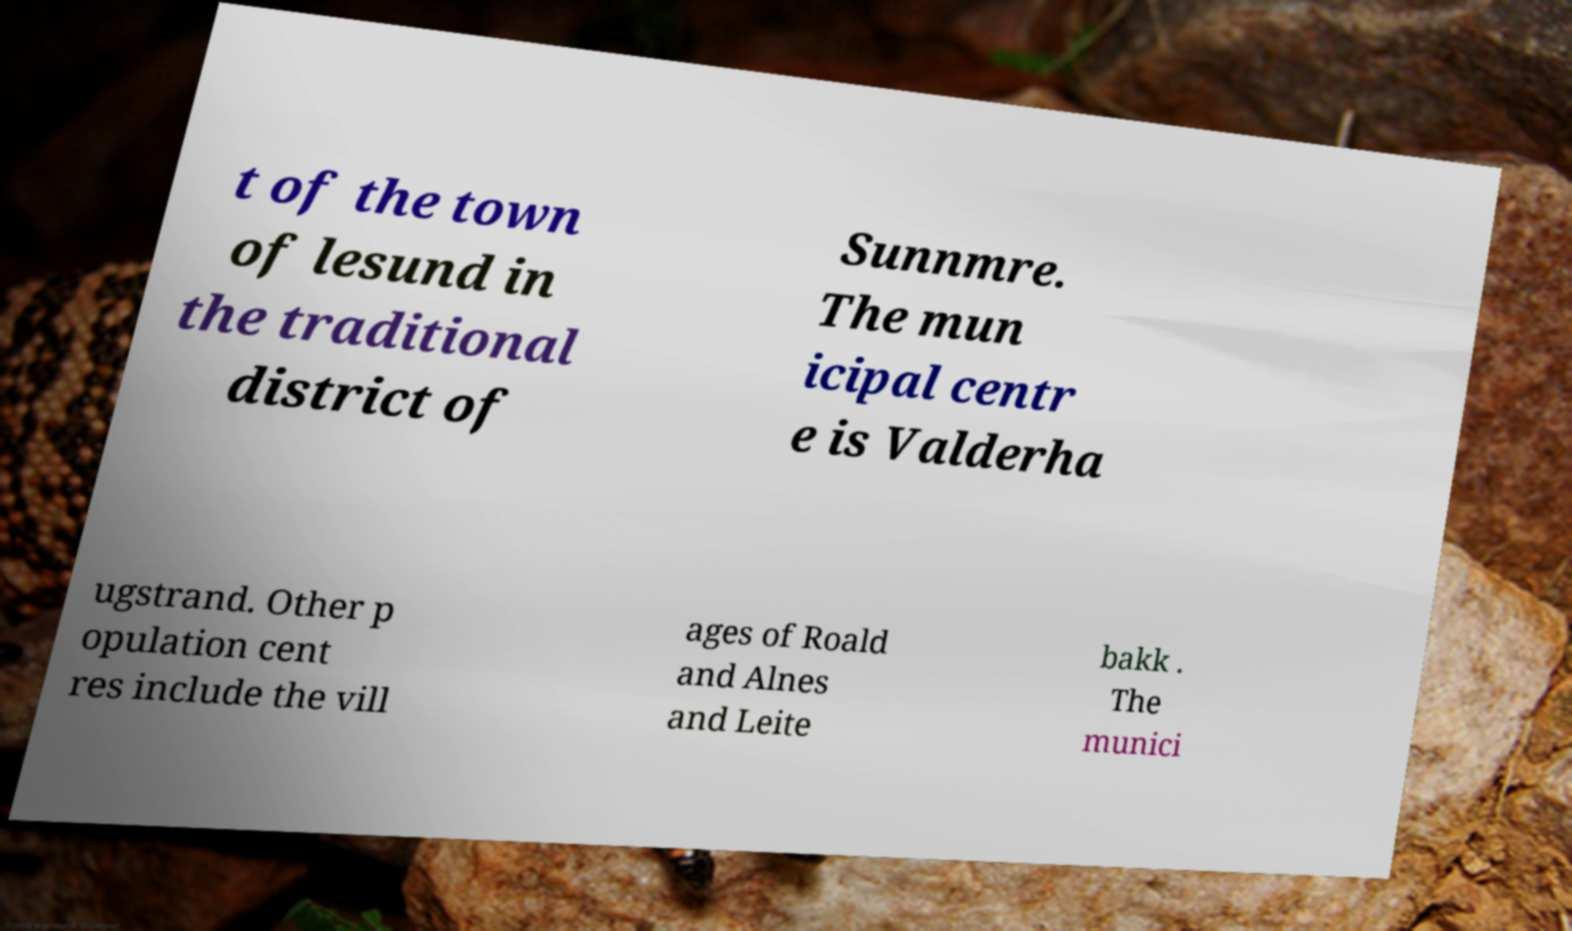Could you extract and type out the text from this image? t of the town of lesund in the traditional district of Sunnmre. The mun icipal centr e is Valderha ugstrand. Other p opulation cent res include the vill ages of Roald and Alnes and Leite bakk . The munici 